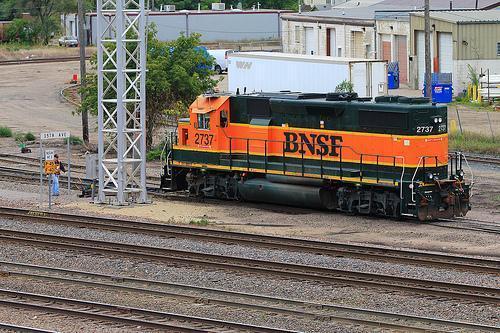How many trains are in the picture?
Give a very brief answer. 1. How many people are in the picture?
Give a very brief answer. 1. 